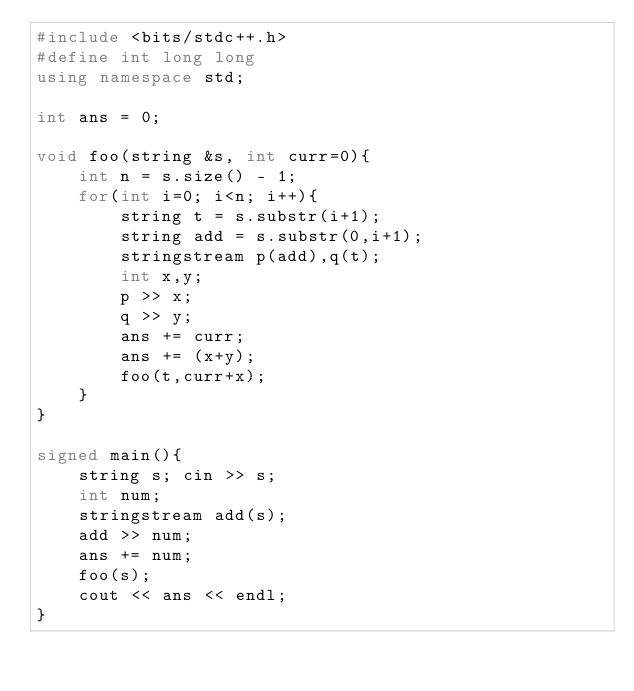<code> <loc_0><loc_0><loc_500><loc_500><_C++_>#include <bits/stdc++.h>
#define int long long
using namespace std;

int ans = 0;

void foo(string &s, int curr=0){
    int n = s.size() - 1;
    for(int i=0; i<n; i++){
        string t = s.substr(i+1);
        string add = s.substr(0,i+1);
        stringstream p(add),q(t);
        int x,y;
        p >> x;
        q >> y;
        ans += curr;
        ans += (x+y);
        foo(t,curr+x);
    }
}

signed main(){
    string s; cin >> s;
    int num;
    stringstream add(s);
    add >> num;
    ans += num;
    foo(s);
    cout << ans << endl;
}</code> 